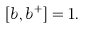<formula> <loc_0><loc_0><loc_500><loc_500>[ b , b ^ { + } ] = 1 .</formula> 